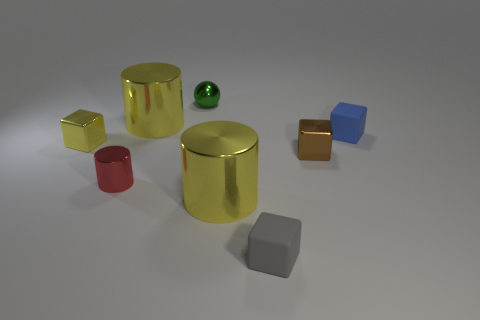Subtract all small gray rubber blocks. How many blocks are left? 3 Subtract all green blocks. Subtract all cyan spheres. How many blocks are left? 4 Add 2 large gray blocks. How many objects exist? 10 Subtract all spheres. How many objects are left? 7 Subtract all tiny shiny cubes. Subtract all blue blocks. How many objects are left? 5 Add 4 tiny metallic cylinders. How many tiny metallic cylinders are left? 5 Add 1 tiny brown rubber objects. How many tiny brown rubber objects exist? 1 Subtract 1 yellow cylinders. How many objects are left? 7 